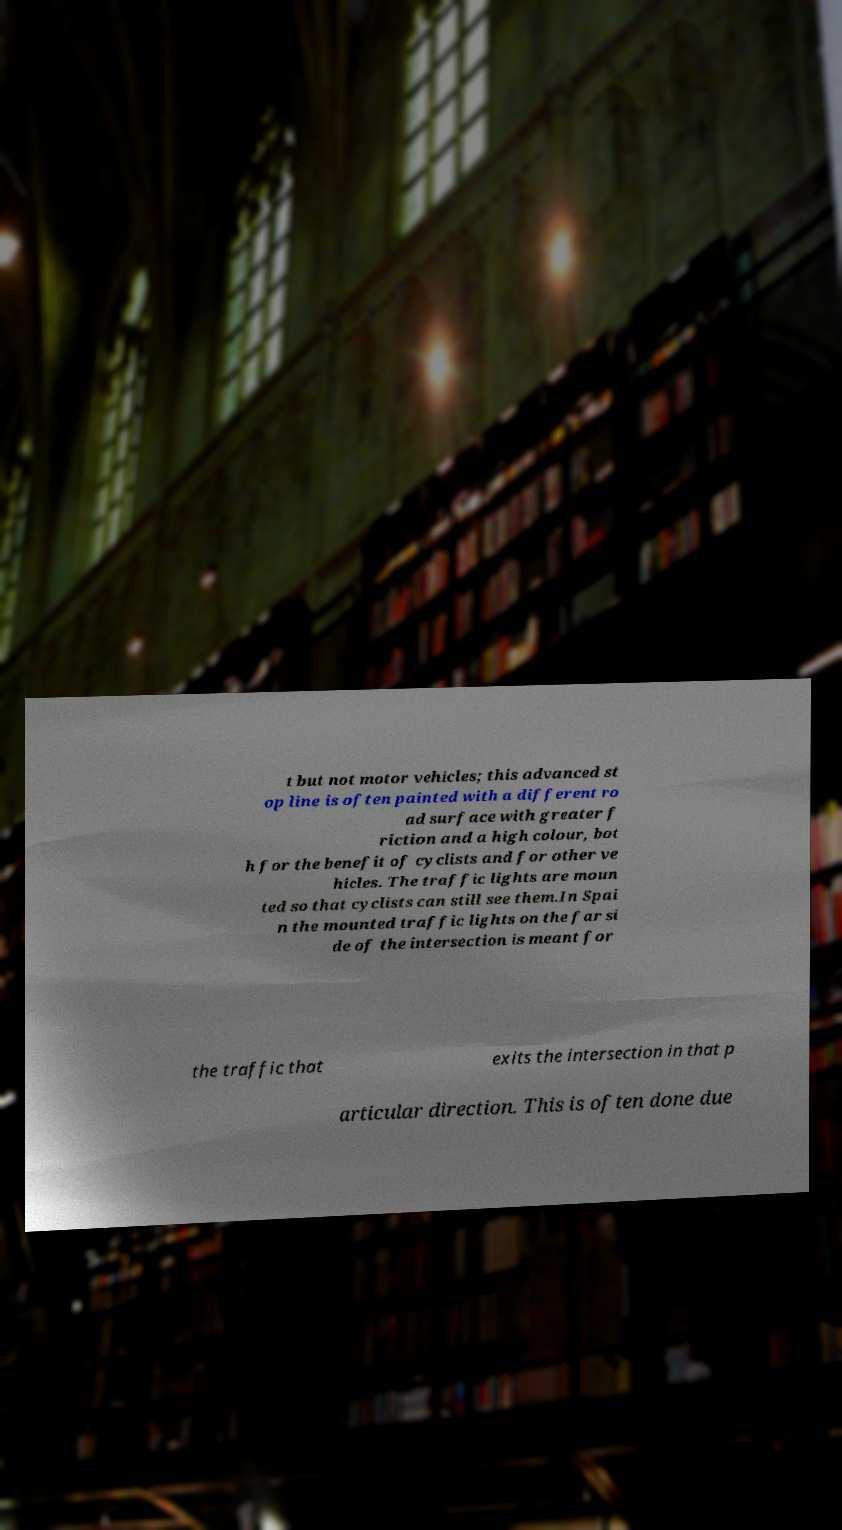What messages or text are displayed in this image? I need them in a readable, typed format. t but not motor vehicles; this advanced st op line is often painted with a different ro ad surface with greater f riction and a high colour, bot h for the benefit of cyclists and for other ve hicles. The traffic lights are moun ted so that cyclists can still see them.In Spai n the mounted traffic lights on the far si de of the intersection is meant for the traffic that exits the intersection in that p articular direction. This is often done due 